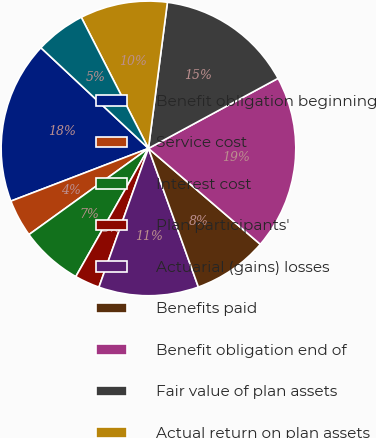Convert chart to OTSL. <chart><loc_0><loc_0><loc_500><loc_500><pie_chart><fcel>Benefit obligation beginning<fcel>Service cost<fcel>Interest cost<fcel>Plan participants'<fcel>Actuarial (gains) losses<fcel>Benefits paid<fcel>Benefit obligation end of<fcel>Fair value of plan assets<fcel>Actual return on plan assets<fcel>Employer contributions<nl><fcel>17.8%<fcel>4.12%<fcel>6.85%<fcel>2.75%<fcel>10.96%<fcel>8.22%<fcel>19.17%<fcel>15.06%<fcel>9.59%<fcel>5.49%<nl></chart> 